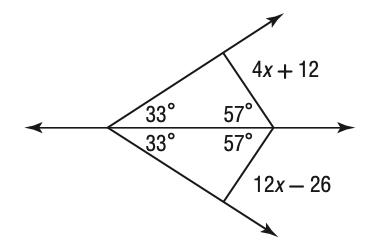Question: Solve for x in the figure below.
Choices:
A. 1.75
B. 2
C. 2.375
D. 4.75
Answer with the letter. Answer: D 